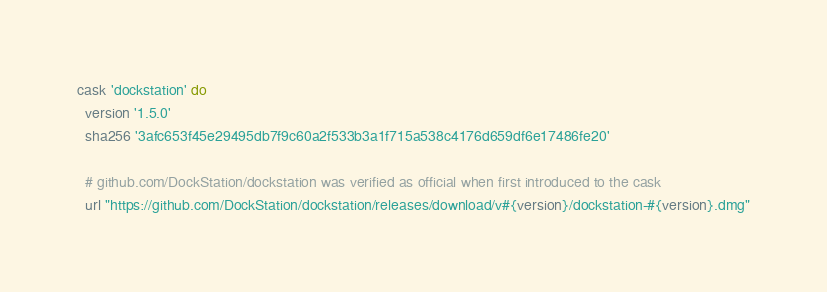<code> <loc_0><loc_0><loc_500><loc_500><_Ruby_>cask 'dockstation' do
  version '1.5.0'
  sha256 '3afc653f45e29495db7f9c60a2f533b3a1f715a538c4176d659df6e17486fe20'

  # github.com/DockStation/dockstation was verified as official when first introduced to the cask
  url "https://github.com/DockStation/dockstation/releases/download/v#{version}/dockstation-#{version}.dmg"</code> 